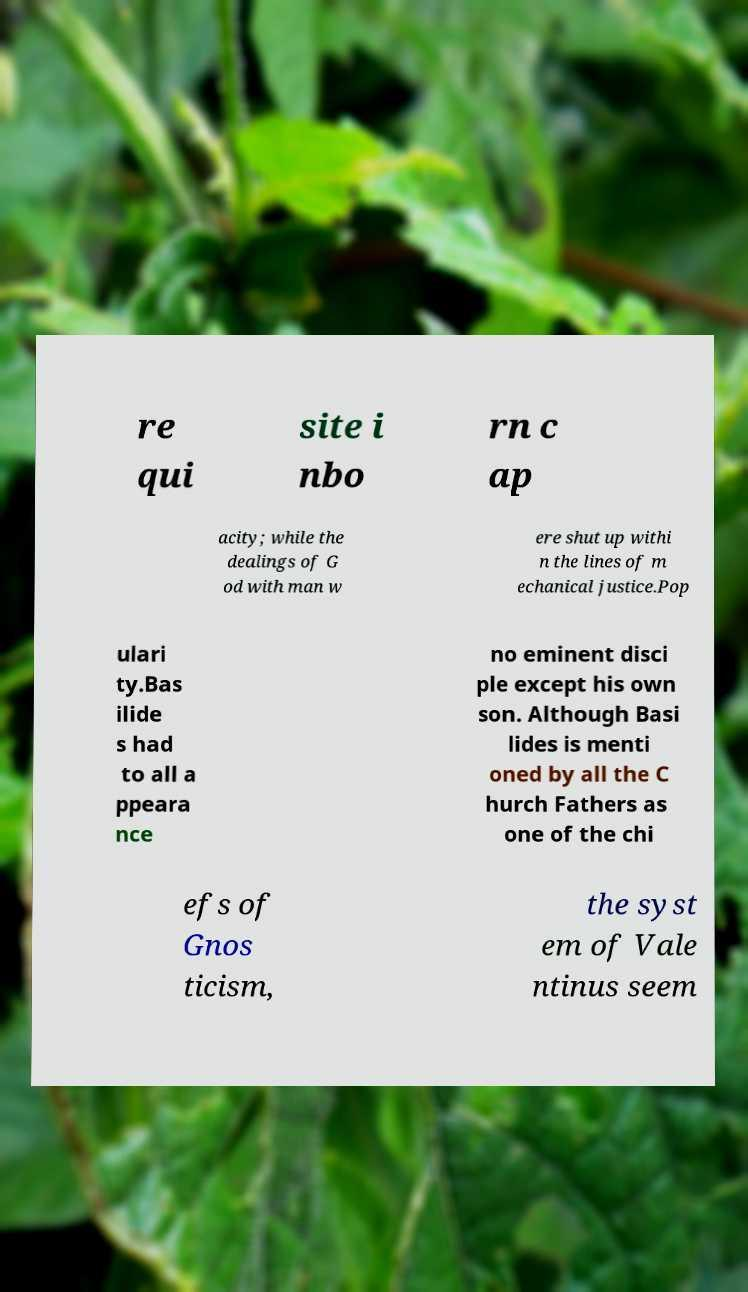Can you read and provide the text displayed in the image?This photo seems to have some interesting text. Can you extract and type it out for me? re qui site i nbo rn c ap acity; while the dealings of G od with man w ere shut up withi n the lines of m echanical justice.Pop ulari ty.Bas ilide s had to all a ppeara nce no eminent disci ple except his own son. Although Basi lides is menti oned by all the C hurch Fathers as one of the chi efs of Gnos ticism, the syst em of Vale ntinus seem 